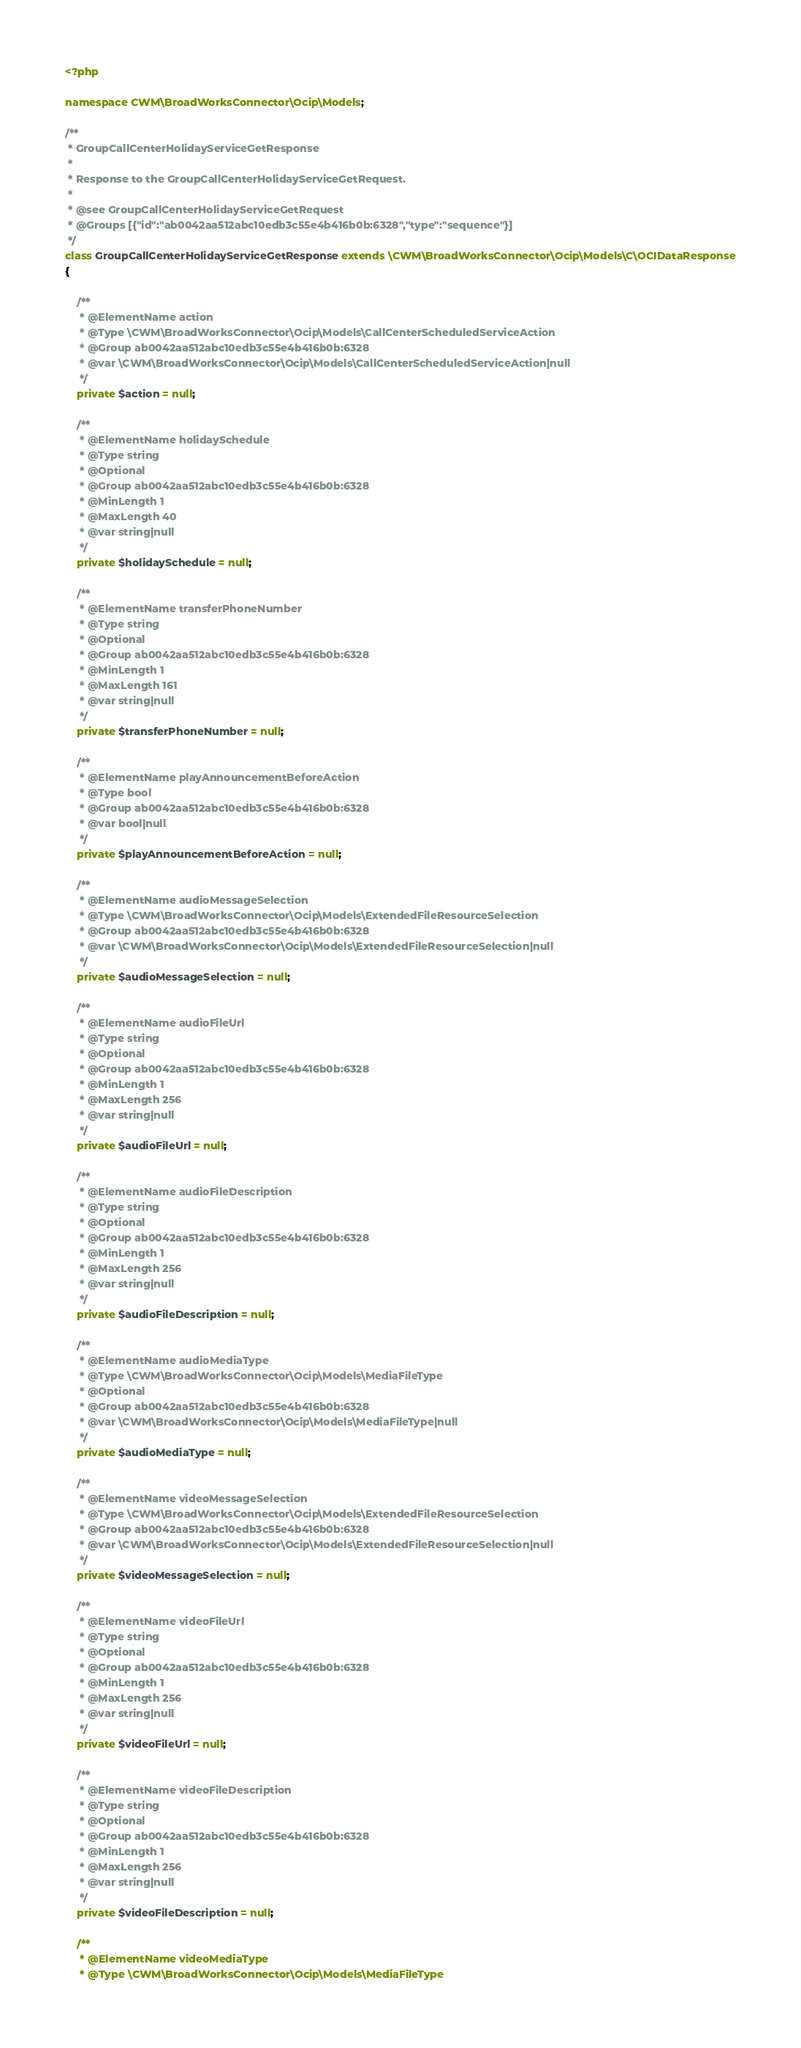Convert code to text. <code><loc_0><loc_0><loc_500><loc_500><_PHP_><?php

namespace CWM\BroadWorksConnector\Ocip\Models;

/**
 * GroupCallCenterHolidayServiceGetResponse
 *
 * Response to the GroupCallCenterHolidayServiceGetRequest.
 *
 * @see GroupCallCenterHolidayServiceGetRequest
 * @Groups [{"id":"ab0042aa512abc10edb3c55e4b416b0b:6328","type":"sequence"}]
 */
class GroupCallCenterHolidayServiceGetResponse extends \CWM\BroadWorksConnector\Ocip\Models\C\OCIDataResponse
{

    /**
     * @ElementName action
     * @Type \CWM\BroadWorksConnector\Ocip\Models\CallCenterScheduledServiceAction
     * @Group ab0042aa512abc10edb3c55e4b416b0b:6328
     * @var \CWM\BroadWorksConnector\Ocip\Models\CallCenterScheduledServiceAction|null
     */
    private $action = null;

    /**
     * @ElementName holidaySchedule
     * @Type string
     * @Optional
     * @Group ab0042aa512abc10edb3c55e4b416b0b:6328
     * @MinLength 1
     * @MaxLength 40
     * @var string|null
     */
    private $holidaySchedule = null;

    /**
     * @ElementName transferPhoneNumber
     * @Type string
     * @Optional
     * @Group ab0042aa512abc10edb3c55e4b416b0b:6328
     * @MinLength 1
     * @MaxLength 161
     * @var string|null
     */
    private $transferPhoneNumber = null;

    /**
     * @ElementName playAnnouncementBeforeAction
     * @Type bool
     * @Group ab0042aa512abc10edb3c55e4b416b0b:6328
     * @var bool|null
     */
    private $playAnnouncementBeforeAction = null;

    /**
     * @ElementName audioMessageSelection
     * @Type \CWM\BroadWorksConnector\Ocip\Models\ExtendedFileResourceSelection
     * @Group ab0042aa512abc10edb3c55e4b416b0b:6328
     * @var \CWM\BroadWorksConnector\Ocip\Models\ExtendedFileResourceSelection|null
     */
    private $audioMessageSelection = null;

    /**
     * @ElementName audioFileUrl
     * @Type string
     * @Optional
     * @Group ab0042aa512abc10edb3c55e4b416b0b:6328
     * @MinLength 1
     * @MaxLength 256
     * @var string|null
     */
    private $audioFileUrl = null;

    /**
     * @ElementName audioFileDescription
     * @Type string
     * @Optional
     * @Group ab0042aa512abc10edb3c55e4b416b0b:6328
     * @MinLength 1
     * @MaxLength 256
     * @var string|null
     */
    private $audioFileDescription = null;

    /**
     * @ElementName audioMediaType
     * @Type \CWM\BroadWorksConnector\Ocip\Models\MediaFileType
     * @Optional
     * @Group ab0042aa512abc10edb3c55e4b416b0b:6328
     * @var \CWM\BroadWorksConnector\Ocip\Models\MediaFileType|null
     */
    private $audioMediaType = null;

    /**
     * @ElementName videoMessageSelection
     * @Type \CWM\BroadWorksConnector\Ocip\Models\ExtendedFileResourceSelection
     * @Group ab0042aa512abc10edb3c55e4b416b0b:6328
     * @var \CWM\BroadWorksConnector\Ocip\Models\ExtendedFileResourceSelection|null
     */
    private $videoMessageSelection = null;

    /**
     * @ElementName videoFileUrl
     * @Type string
     * @Optional
     * @Group ab0042aa512abc10edb3c55e4b416b0b:6328
     * @MinLength 1
     * @MaxLength 256
     * @var string|null
     */
    private $videoFileUrl = null;

    /**
     * @ElementName videoFileDescription
     * @Type string
     * @Optional
     * @Group ab0042aa512abc10edb3c55e4b416b0b:6328
     * @MinLength 1
     * @MaxLength 256
     * @var string|null
     */
    private $videoFileDescription = null;

    /**
     * @ElementName videoMediaType
     * @Type \CWM\BroadWorksConnector\Ocip\Models\MediaFileType</code> 